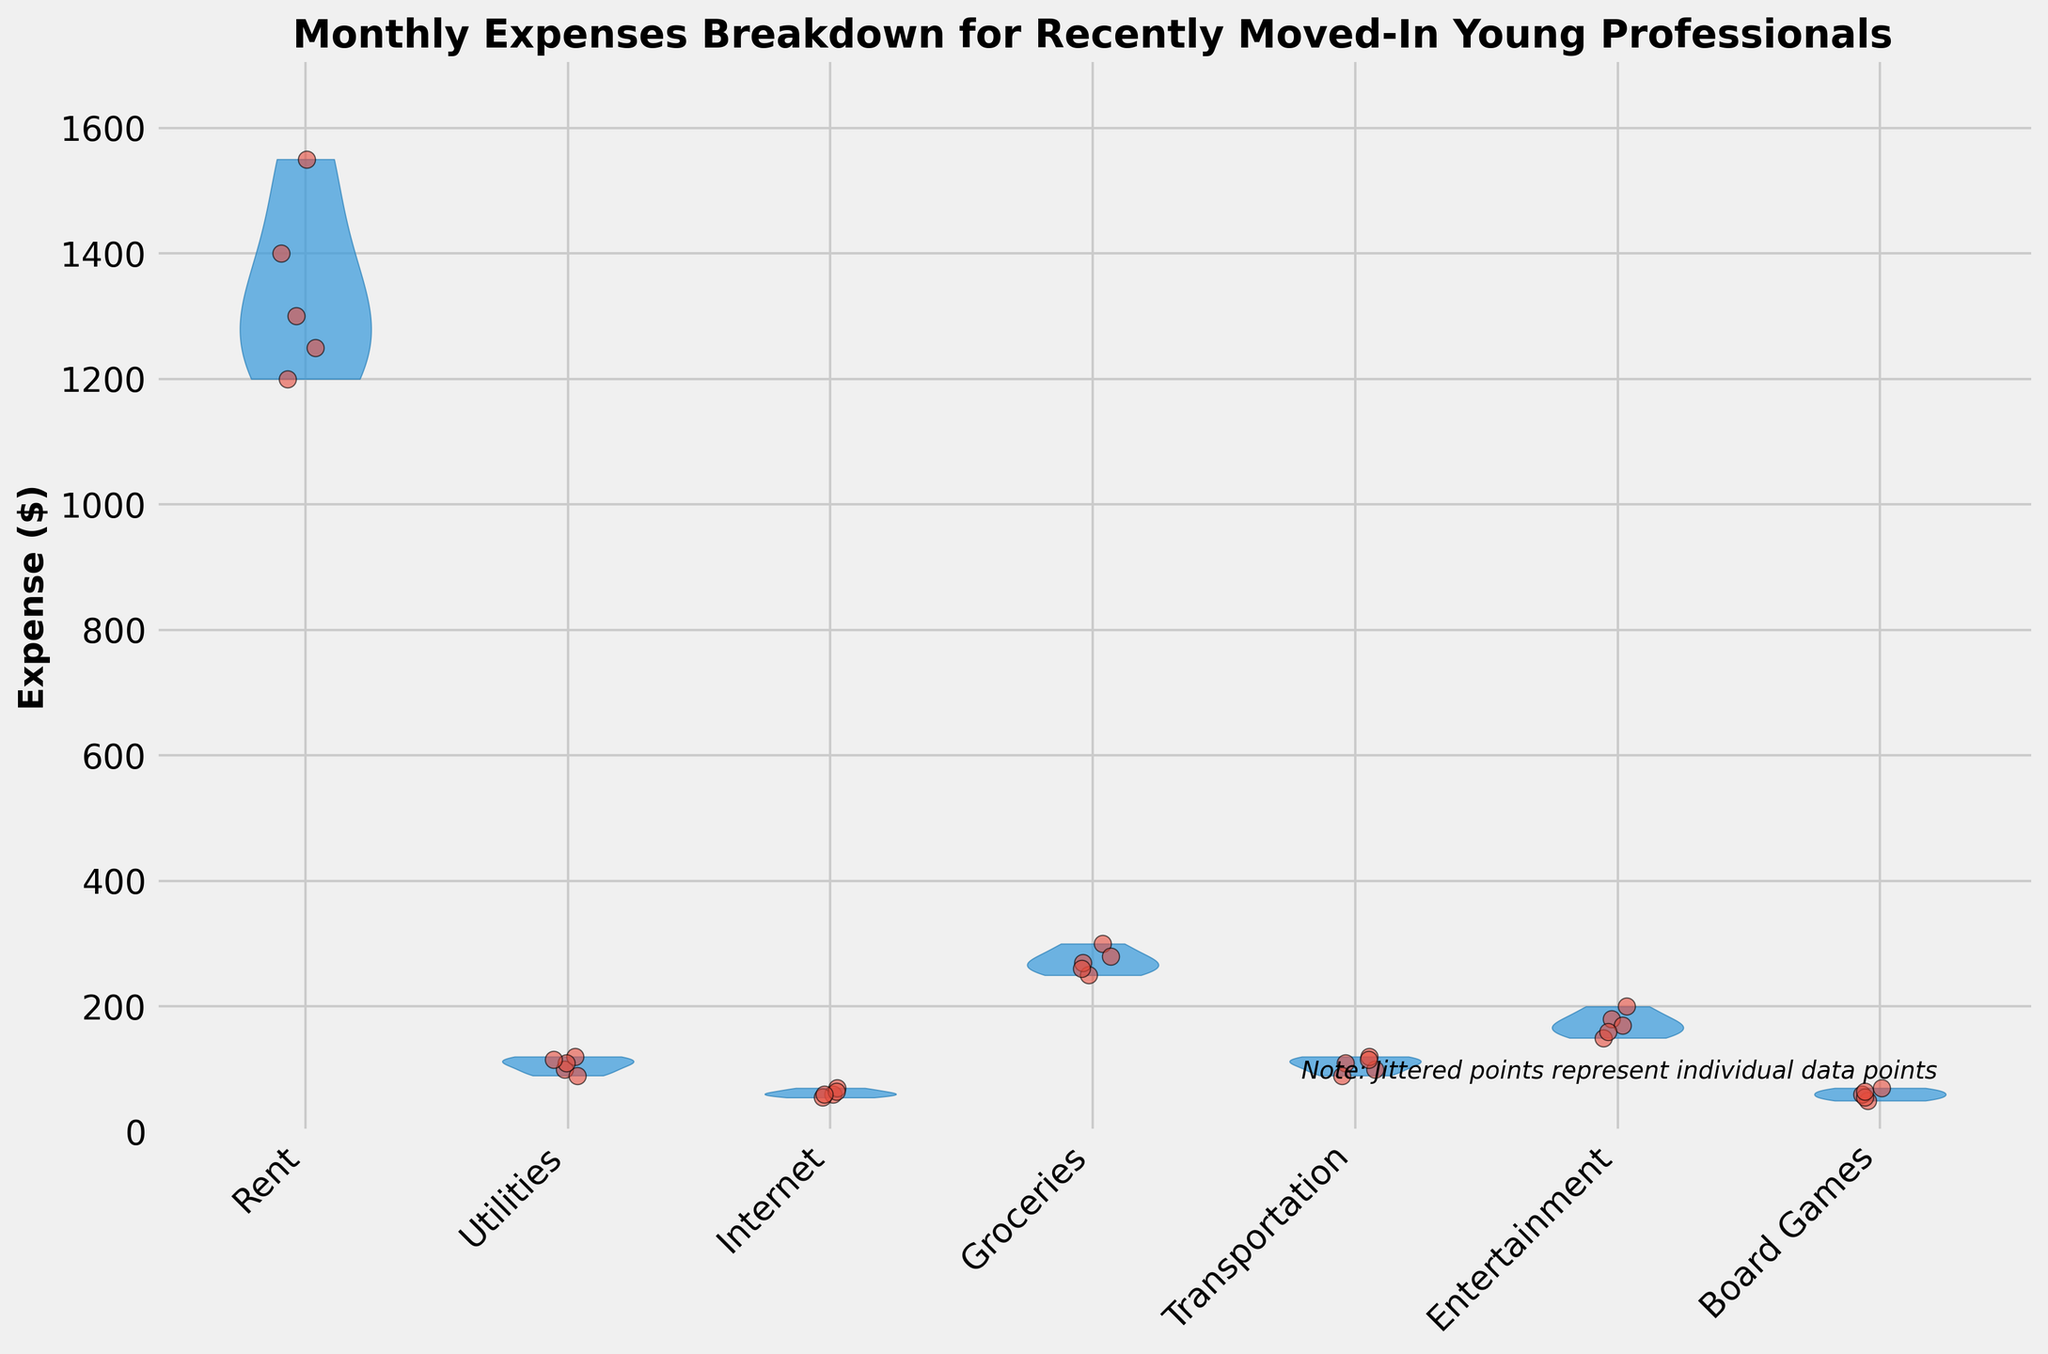What's the title of the figure? The title is usually displayed at the top of the plot. It provides a summary or the main topic of the chart. In this case, it indicates the data is about monthly expenses for recently moved-in young professionals.
Answer: Monthly Expenses Breakdown for Recently Moved-In Young Professionals What is the y-axis label? The y-axis label gives information about what is measured along the y-axis. In this case, it shows the type of value being measured, which is the expense in dollars.
Answer: Expense ($) How many expense categories are shown? Count the number of unique categories on the x-axis of the plot. Each jittered point belongs to one of these categories.
Answer: 7 Which category has the highest maximum expense? By visually examining the highest points within each category in the violin plots, we can determine which category reaches the highest value. Rent, with expenses going up to around $1550, stands out as the highest.
Answer: Rent Which category shows the most variation in expense amounts? By observing the width of the violins and the spread of jittered points, identify the category with the widest spread. Rent shows the broadest range, indicating the most variation.
Answer: Rent What is the approximate range of expenses for Utilities? Find the minimum and maximum values for the jittered points within the "Utilities" category and calculate their range. The points range from $90 to $120.
Answer: $30 How does the median expense for Internet compare to that for Groceries? Determine the central tendency of the expenses in each category. The median can be inferred from the density of points and the violin's shape. The Internet median appears around $60-$65, while Groceries’ median is around $270.
Answer: Lower for Internet How do the jittered points help in understanding the data? Jittered points show the individual expense data points overlaid on the violin plot, making it easier to see variation and distribution within each category. The random horizontal spread prevents them from overlapping, giving a clearer picture.
Answer: Show individual data points Which categories show expenses clustering very closely together? Observing the jittered points' dispersion within each violin plot, Internet and Board Games show closely clustered expenses, indicating less variation.
Answer: Internet and Board Games What additional information might be inferred from the note "Note: Jittered points represent individual data points"? This note clarifies that each point represents an individual expense, allowing us to understand the density and actual values within each category rather than just the overall distribution implied by the violin shapes.
Answer: Represents individual data points 